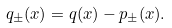Convert formula to latex. <formula><loc_0><loc_0><loc_500><loc_500>q _ { \pm } ( x ) = q ( x ) - p _ { \pm } ( x ) .</formula> 